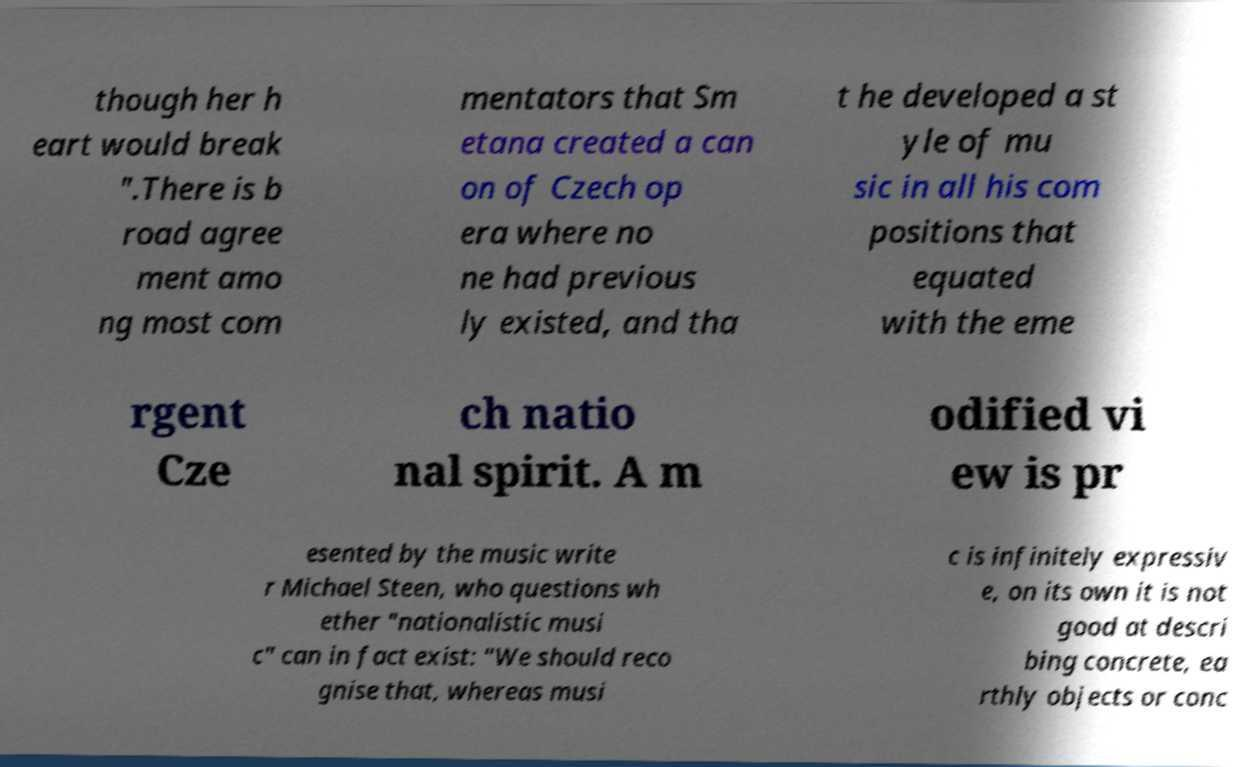Could you extract and type out the text from this image? though her h eart would break ".There is b road agree ment amo ng most com mentators that Sm etana created a can on of Czech op era where no ne had previous ly existed, and tha t he developed a st yle of mu sic in all his com positions that equated with the eme rgent Cze ch natio nal spirit. A m odified vi ew is pr esented by the music write r Michael Steen, who questions wh ether "nationalistic musi c" can in fact exist: "We should reco gnise that, whereas musi c is infinitely expressiv e, on its own it is not good at descri bing concrete, ea rthly objects or conc 